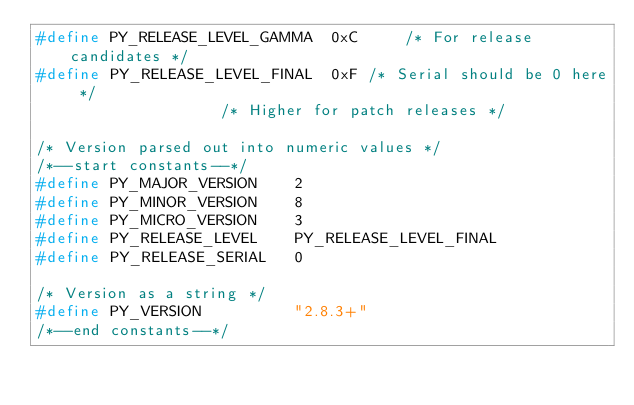Convert code to text. <code><loc_0><loc_0><loc_500><loc_500><_C_>#define PY_RELEASE_LEVEL_GAMMA	0xC     /* For release candidates */
#define PY_RELEASE_LEVEL_FINAL	0xF	/* Serial should be 0 here */
					/* Higher for patch releases */

/* Version parsed out into numeric values */
/*--start constants--*/
#define PY_MAJOR_VERSION	2
#define PY_MINOR_VERSION	8
#define PY_MICRO_VERSION	3
#define PY_RELEASE_LEVEL	PY_RELEASE_LEVEL_FINAL
#define PY_RELEASE_SERIAL	0

/* Version as a string */
#define PY_VERSION      	"2.8.3+"
/*--end constants--*/
</code> 